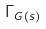<formula> <loc_0><loc_0><loc_500><loc_500>\Gamma _ { G ( s ) }</formula> 